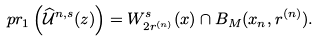Convert formula to latex. <formula><loc_0><loc_0><loc_500><loc_500>p r _ { 1 } \left ( \widehat { \mathcal { U } } ^ { n , s } ( z ) \right ) = W ^ { s } _ { 2 r ^ { ( n ) } } ( x ) \cap B _ { M } ( x _ { n } , r ^ { ( n ) } ) .</formula> 